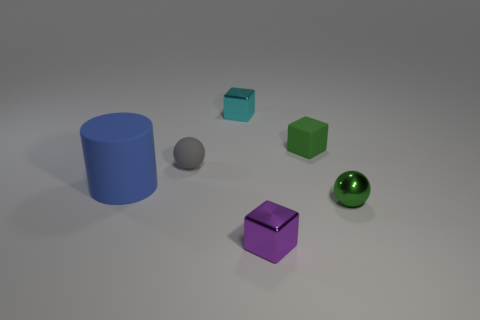Subtract all metal cubes. How many cubes are left? 1 Add 1 gray matte objects. How many objects exist? 7 Subtract all blue cubes. Subtract all brown balls. How many cubes are left? 3 Subtract all metallic cylinders. Subtract all blue things. How many objects are left? 5 Add 6 tiny gray matte things. How many tiny gray matte things are left? 7 Add 1 green balls. How many green balls exist? 2 Subtract 0 gray cylinders. How many objects are left? 6 Subtract all balls. How many objects are left? 4 